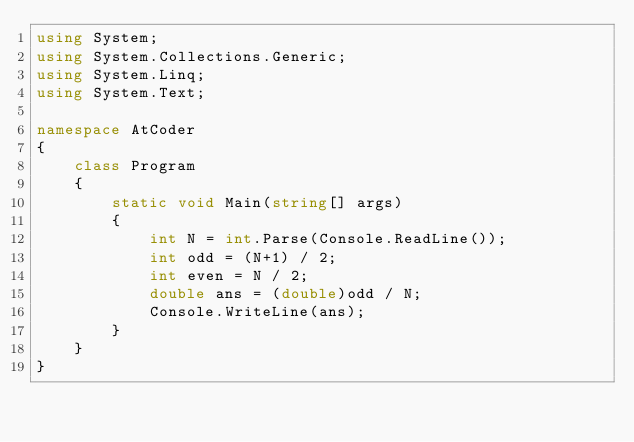Convert code to text. <code><loc_0><loc_0><loc_500><loc_500><_C#_>using System;
using System.Collections.Generic;
using System.Linq;
using System.Text;

namespace AtCoder
{
    class Program
    {
        static void Main(string[] args)
        {
            int N = int.Parse(Console.ReadLine());
            int odd = (N+1) / 2;
            int even = N / 2;
            double ans = (double)odd / N;
            Console.WriteLine(ans);
        }
    }
}</code> 